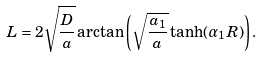<formula> <loc_0><loc_0><loc_500><loc_500>L = 2 \sqrt { \frac { D } { a } } \arctan \left ( \sqrt { \frac { a _ { 1 } } { a } } \tanh ( \alpha _ { 1 } R ) \right ) .</formula> 